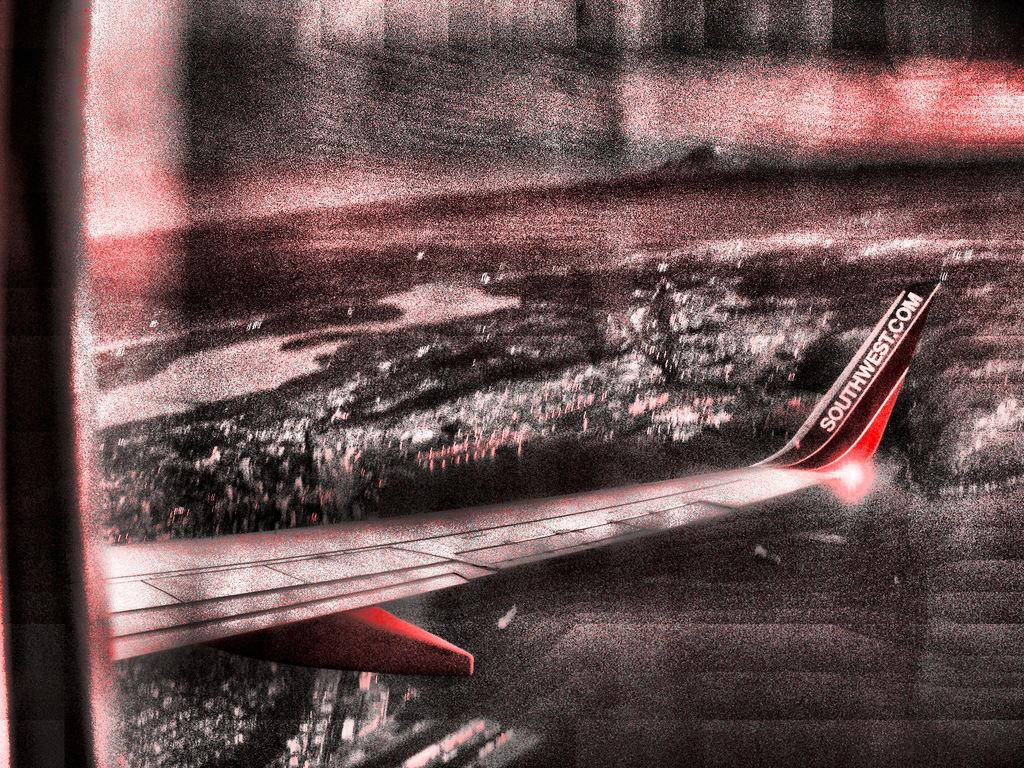What website is on the plane wing?
Your response must be concise. Southwest.com. What is wrote on the plane?
Ensure brevity in your answer.  Southwest.com. 